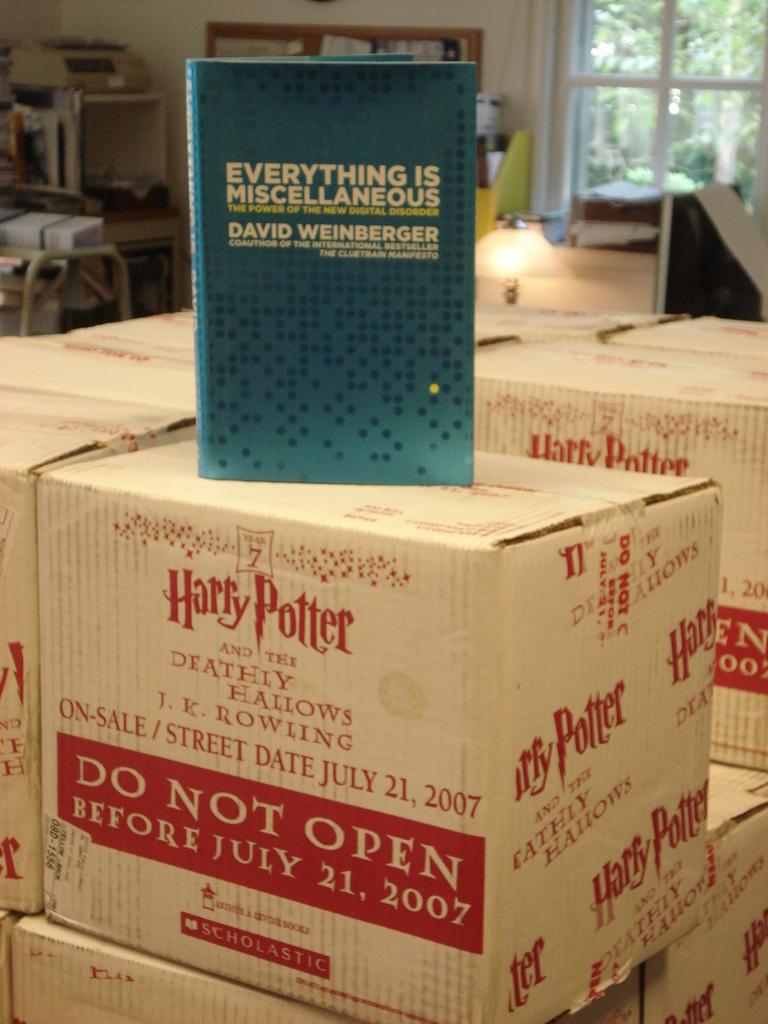What is the street date for the harry potter book?
Your answer should be very brief. July 21, 2007. What book is on top of boxes?
Your response must be concise. Everything is miscellaneous. 